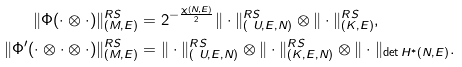Convert formula to latex. <formula><loc_0><loc_0><loc_500><loc_500>\| \Phi ( \cdot \otimes \cdot ) \| ^ { R S } _ { ( M , E ) } & = 2 ^ { - \frac { \chi ( N , E ) } { 2 } } \| \cdot \| ^ { R S } _ { ( \ U , E , N ) } \otimes \| \cdot \| ^ { R S } _ { ( K , E ) } , \\ \| \Phi ^ { \prime } ( \cdot \otimes \cdot \otimes \cdot ) \| ^ { R S } _ { ( M , E ) } & = \| \cdot \| ^ { R S } _ { ( \ U , E , N ) } \otimes \| \cdot \| ^ { R S } _ { ( K , E , N ) } \otimes \| \cdot \| _ { \det H ^ { * } ( N , E ) } .</formula> 